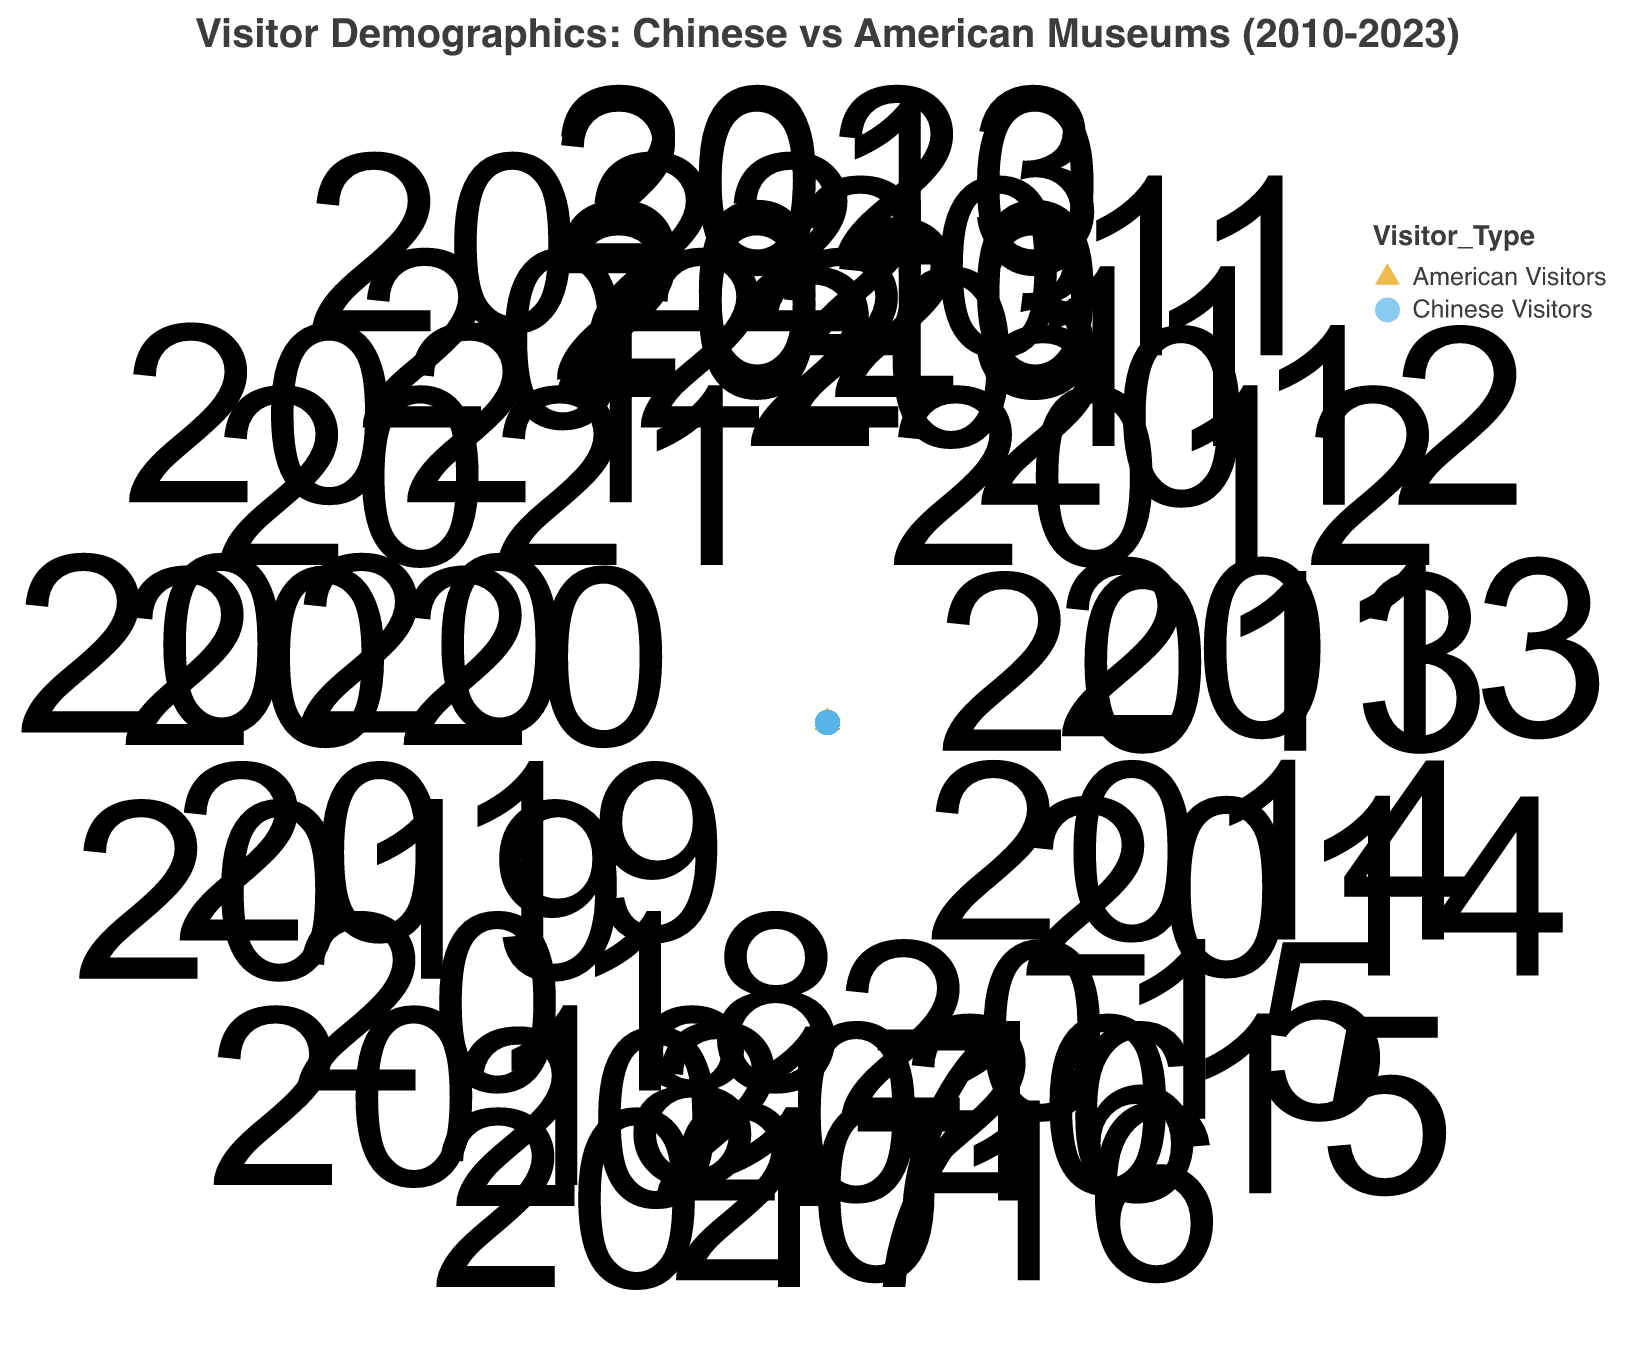what is the total number of visitors for American visitors to National Museum of China and Chinese visitors to Smithsonian National Museum of American History in 2020? In 2020, the number of American visitors to the National Museum of China is 35500. In the same year, the number of Chinese visitors to the Smithsonian National Museum of American History is 57500. Summing these numbers gives 35500 + 57500 = 93000.
Answer: 93000 What trend is visible for Chinese visitors to American museums from 2010 to 2023? The figure shows that the general trend for Chinese visitors to American museums is increasing over the years, with visitor numbers gradually rising from 54000 in 2010 to 56000 in 2023, particularly at the Smithsonian National Museum of American History.
Answer: Increase Does the data show a year when the visitor numbers dropped significantly for American visitors to Chinese museums? Yes, there is a noticeable drop in visitor numbers for American visitors at the Nanjing Museum in 2013, where the number decreased to 27500 compared to other years.
Answer: 2013 Which type of visitors is represented by the triangle shapes in the figure? The triangle shapes represent the number of visitors who are Americans visiting museums in China.
Answer: American Visitors How do the maximum visitor counts compare between American visitors to Chinese museums and Chinese visitors to American museums? The maximum number of visitors for American visitors to Chinese museums is 35500 in 2020 at the National Museum of China. The maximum number of visitors for Chinese visitors to American museums is 57500 in 2020 at the Smithsonian National Museum of American History. Comparing these, the maximum for Chinese visitors to American museums is higher.
Answer: Chinese visitors have higher maximum visitor counts Which years have the highest number of visitors for American visitors in Chinese museums and Chinese visitors in American museums? For American visitors to Chinese museums, the year with the highest number of visitors is 2020 with 35500 visitors. For Chinese visitors to American museums, 2020 also has the highest number of visitors with 57500 visitors.
Answer: 2020 What is the average number of American visitors to Shanghai Museum across the years mentioned? The number of visitors for American visitors to Shanghai Museum over the years are 28900 in 2011, 32000 in 2016, and 31000 in 2021. The average is calculated as (28900 + 32000 + 31000) / 3 which equals 30633.33.
Answer: 30633.33 Identify the museum in the United States with the most consistent visitor count through the years for Chinese visitors. Observing the data points, the Smithsonian National Museum of American History has relatively consistent and high visitor counts for Chinese visitors through the years.
Answer: Smithsonian National Museum of American History 